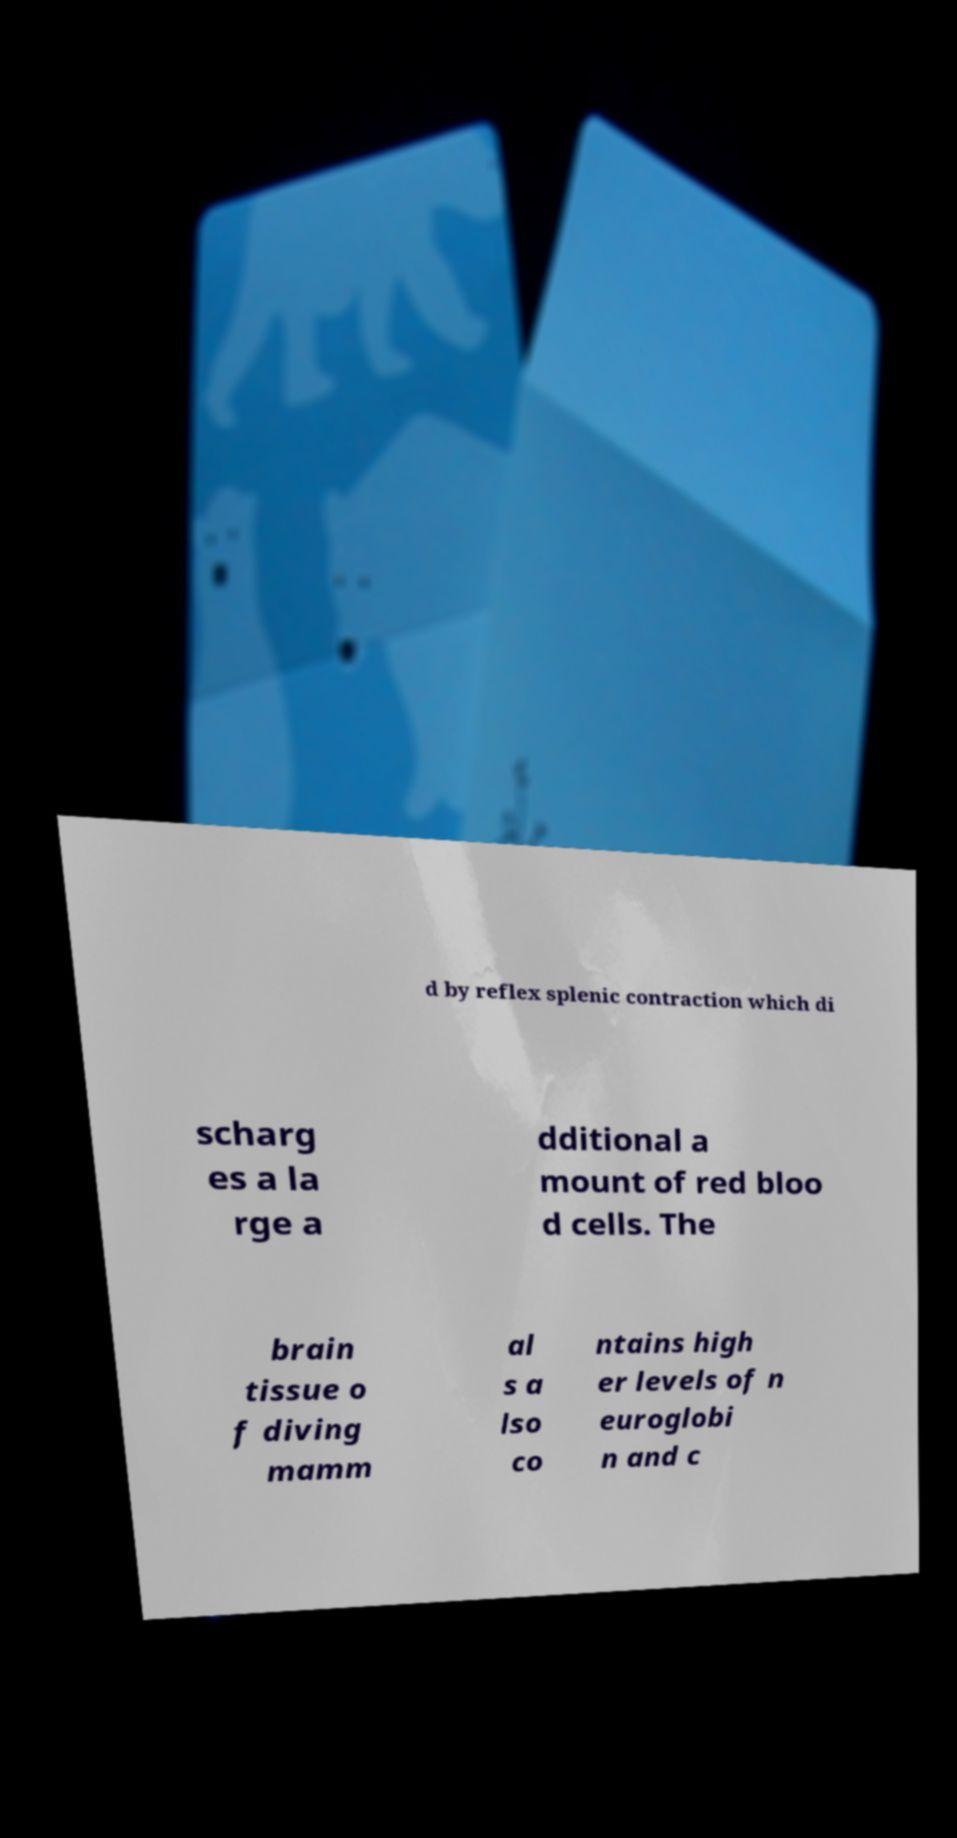Could you assist in decoding the text presented in this image and type it out clearly? d by reflex splenic contraction which di scharg es a la rge a dditional a mount of red bloo d cells. The brain tissue o f diving mamm al s a lso co ntains high er levels of n euroglobi n and c 